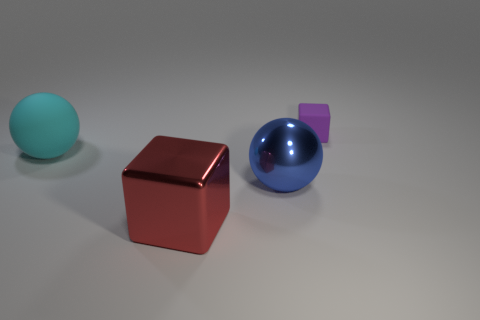Do the small purple thing and the large cyan object have the same shape? no 